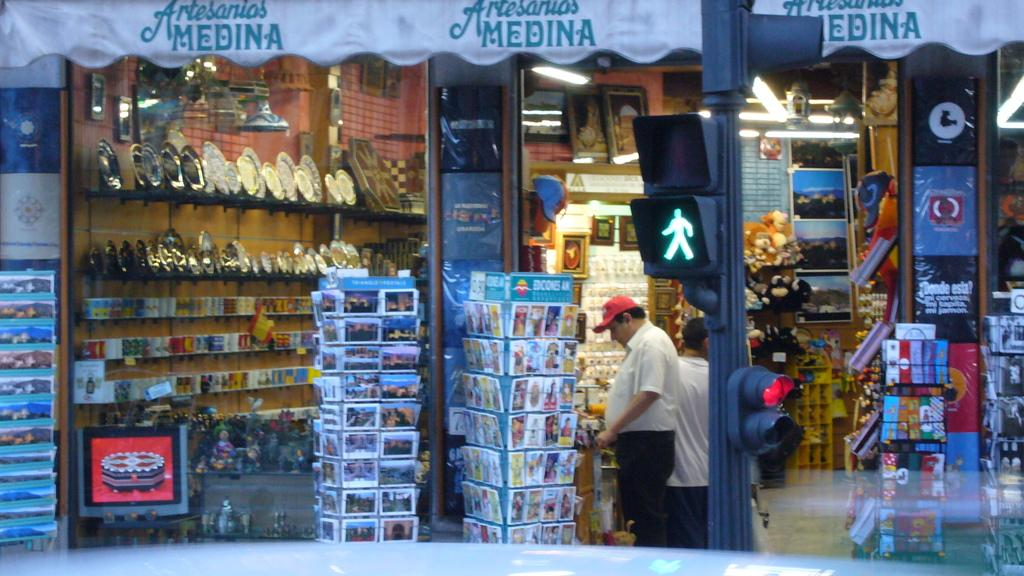<image>
Share a concise interpretation of the image provided. the word medina is on a sign above a store 